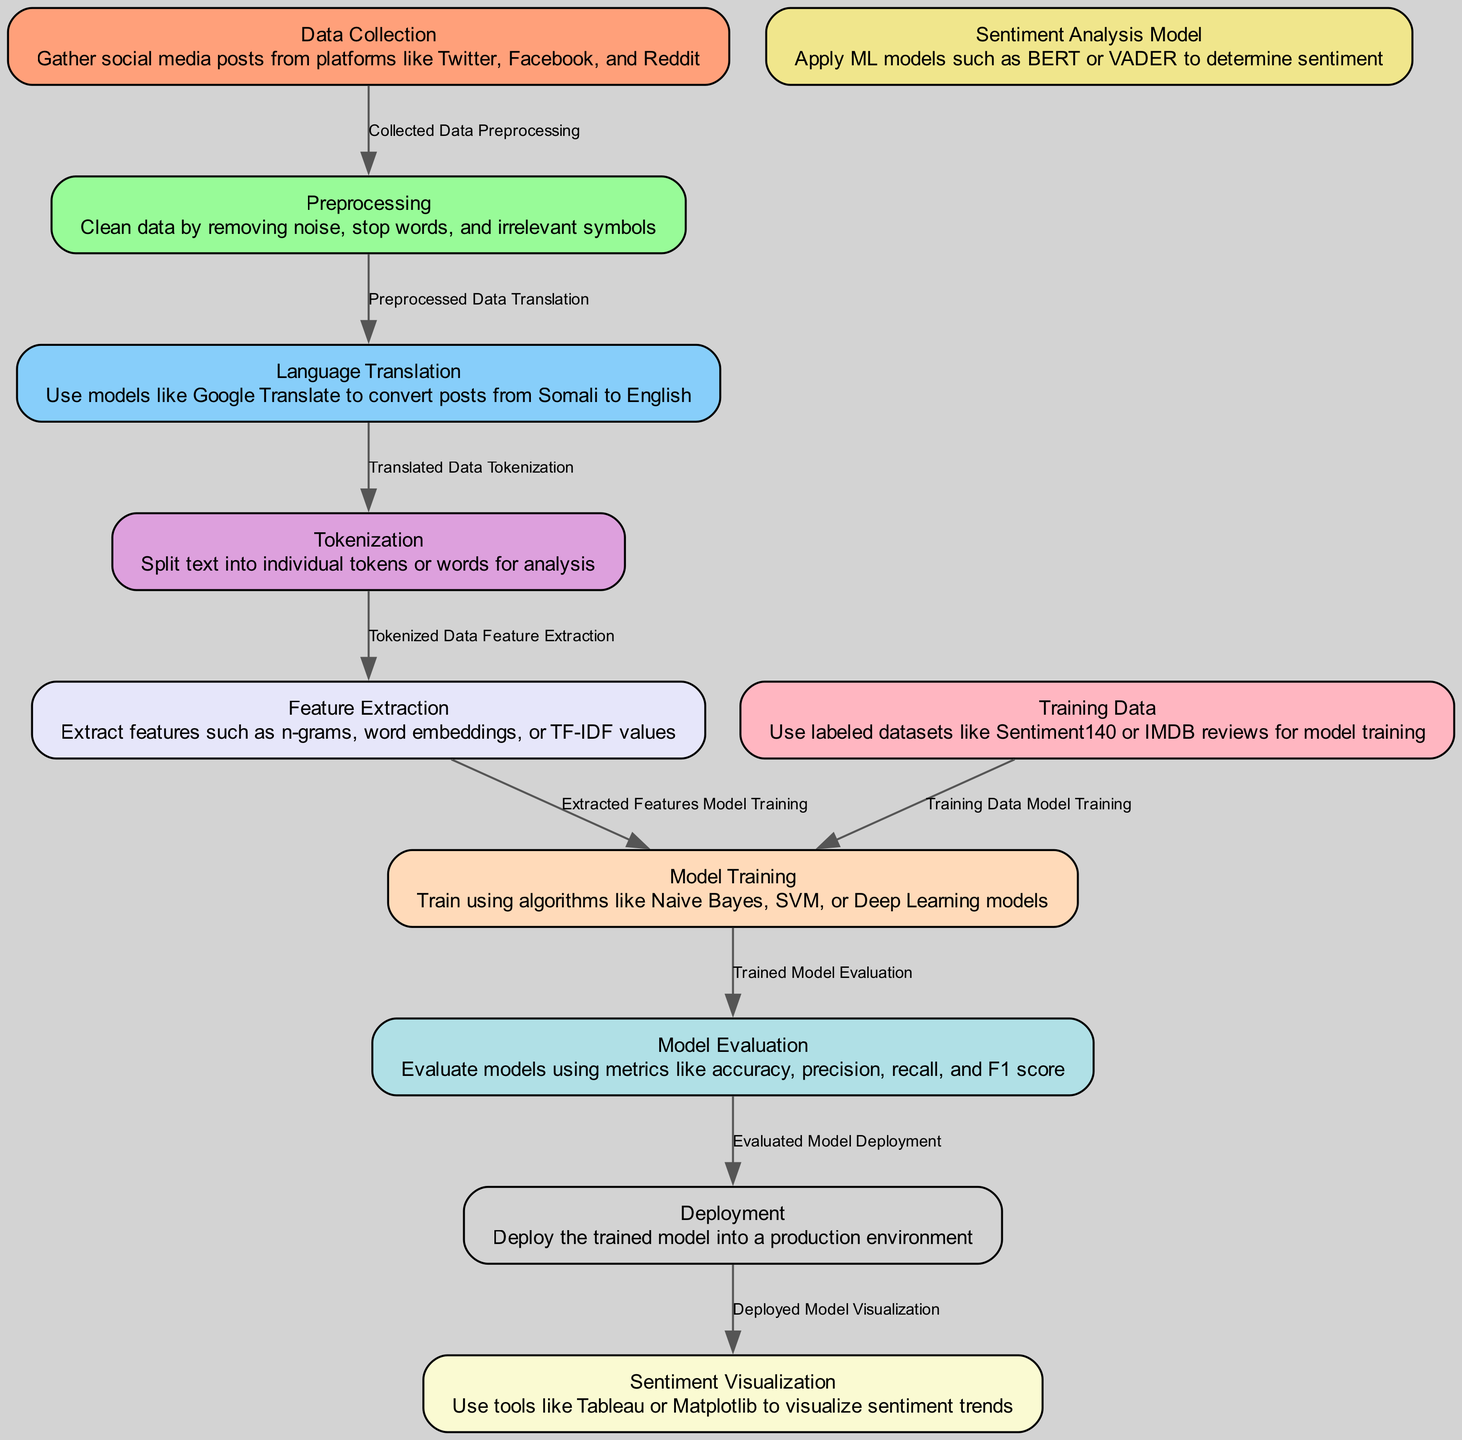What is the first step in the sentiment analysis process? The diagram indicates that the first step is "Data Collection," where social media posts are gathered from various platforms.
Answer: Data Collection How many nodes are present in the diagram? By counting the nodes in the diagram's elements section, there are a total of 11 nodes.
Answer: 11 What type of data is used for model training? The model training uses labeled datasets like Sentiment140 or IMDB reviews, as stated in the "Training Data" node.
Answer: Labeled datasets What comes after "Tokenization" in the process? The diagram shows that after "Tokenization," the next step is "Feature Extraction" where relevant features are extracted for analysis.
Answer: Feature Extraction Which two nodes connect the "Model Training" process? The "Model Training" process is connected by one incoming edge from "Extracted Features" and another from "Training Data." Therefore, the two nodes are "Extracted Features" and "Training Data."
Answer: Extracted Features and Training Data Which sentiment analysis models are mentioned in the diagram? According to the "Sentiment Analysis Model" node, the models mentioned are BERT and VADER, which are commonly used for determining sentiment.
Answer: BERT and VADER What is the final step represented in the diagram? The final step in the process is "Sentiment Visualization," where sentiment trends are visualized using tools like Tableau or Matplotlib.
Answer: Sentiment Visualization How is model evaluation described in the diagram? The "Model Evaluation" node states that models are evaluated using metrics such as accuracy, precision, recall, and F1 score, which assess the model's performance.
Answer: Using metrics like accuracy, precision, recall, and F1 score Which node introduces the aspect of language translation? The "Language Translation" node introduces this aspect, indicating the use of models like Google Translate to convert posts from Somali to English.
Answer: Language Translation 